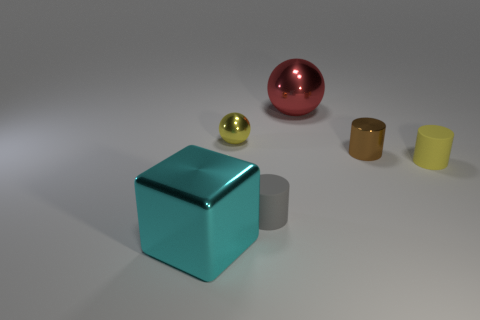The tiny metallic sphere has what color? The tiny metallic sphere appears to be of a golden-yellow color, with a reflective surface that catches the light, giving it a gloss that accentuates its curves and smooth finish. 